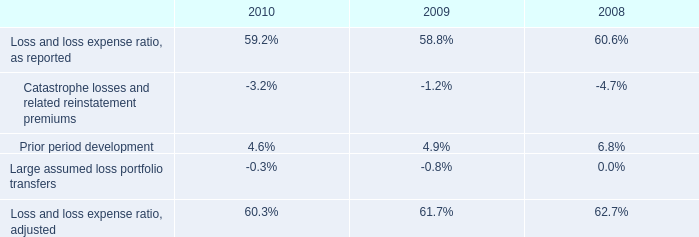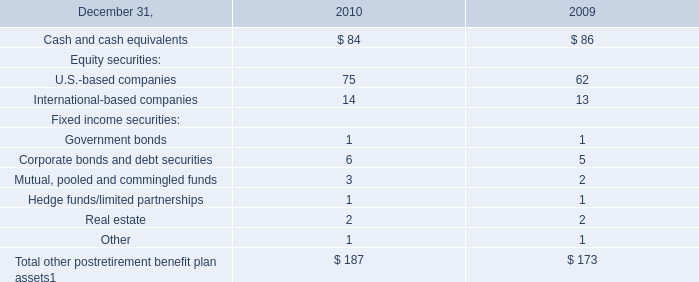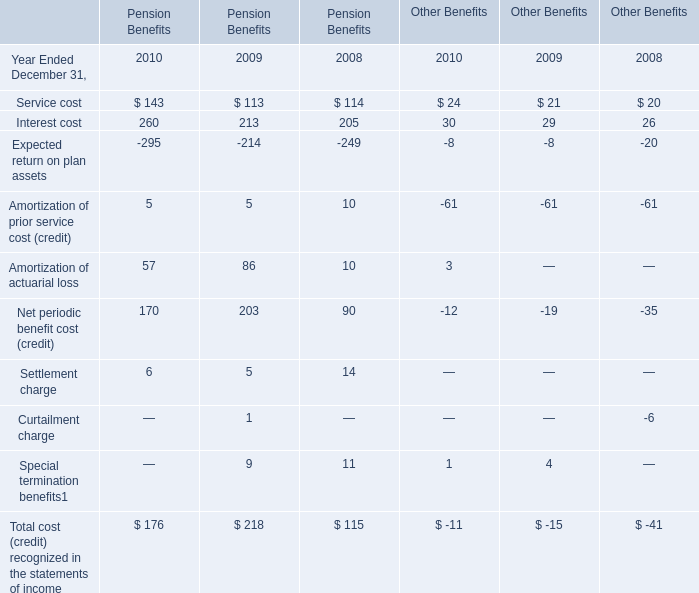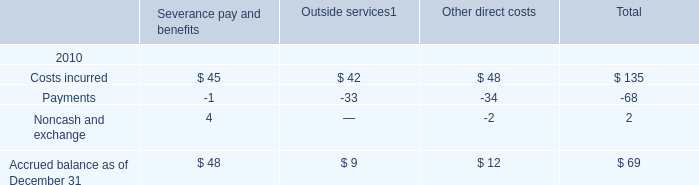If Interest cost for Pension Benefits develops with the same growth rate in 2010, what will it reach in 2011? 
Computations: (260 * (1 + ((260 - 213) / 213)))
Answer: 317.37089. 